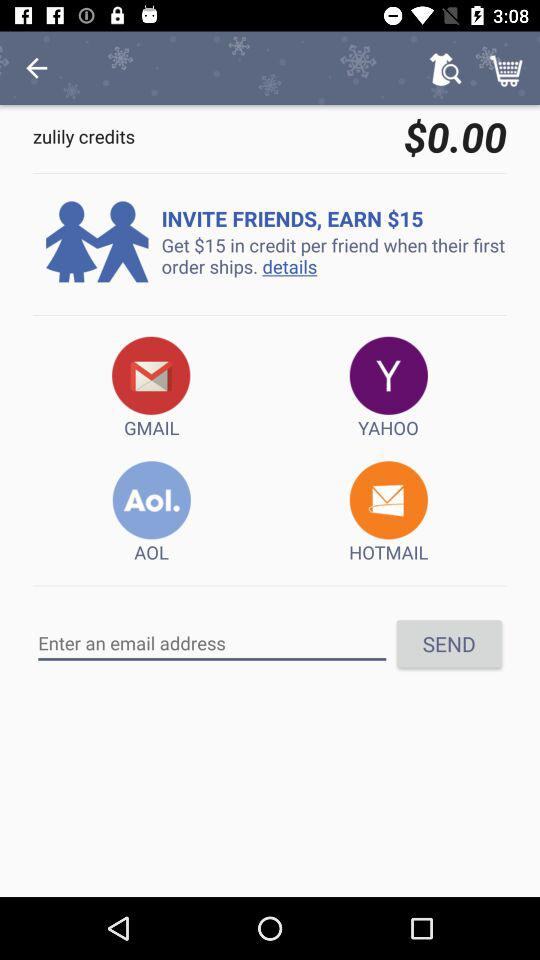How many email providers can I choose from to invite friends?
Answer the question using a single word or phrase. 4 